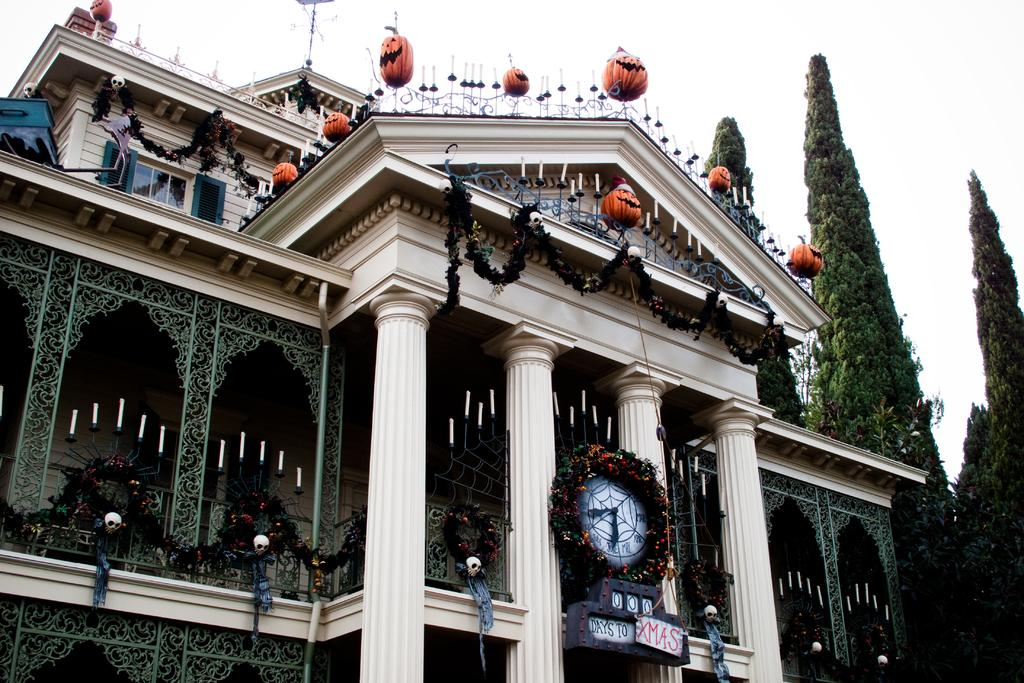What is on the building in the image? There is a clock on a building in the image. What can be seen in the background of the image? There are trees in the background of the image. What type of material is used for the rods visible in the image? The rods visible in the image are made of metal. How does the clock wave to people in the image? The clock does not wave to people in the image; it is a stationary object on the building. 